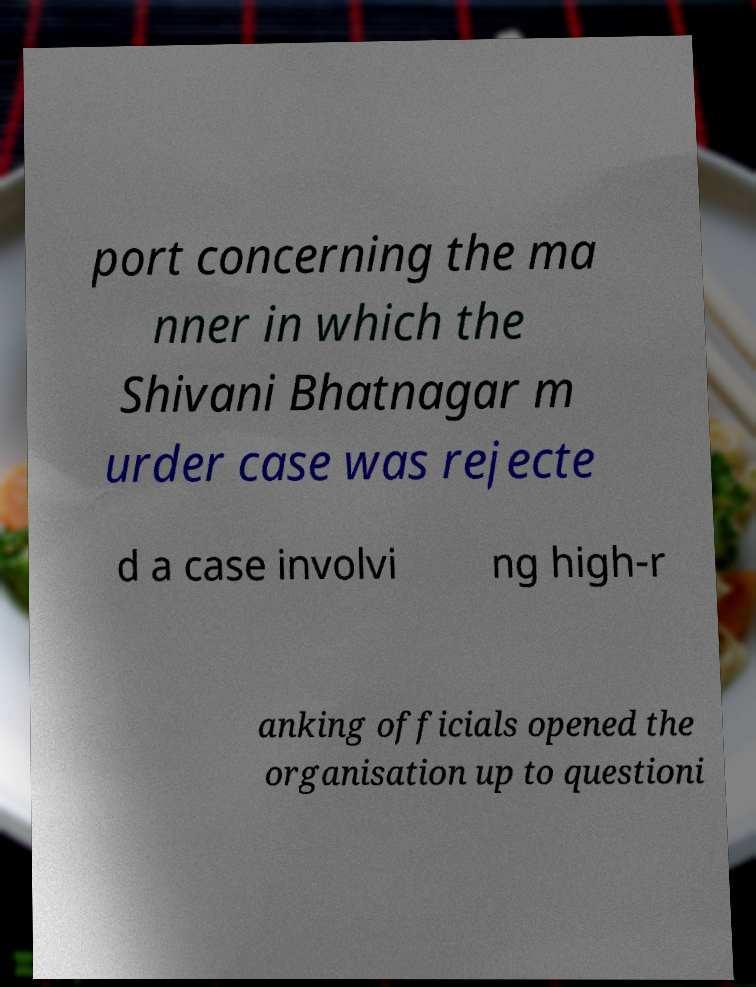Can you accurately transcribe the text from the provided image for me? port concerning the ma nner in which the Shivani Bhatnagar m urder case was rejecte d a case involvi ng high-r anking officials opened the organisation up to questioni 